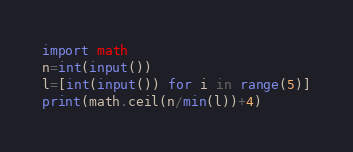<code> <loc_0><loc_0><loc_500><loc_500><_Python_>import math
n=int(input())
l=[int(input()) for i in range(5)]
print(math.ceil(n/min(l))+4)</code> 